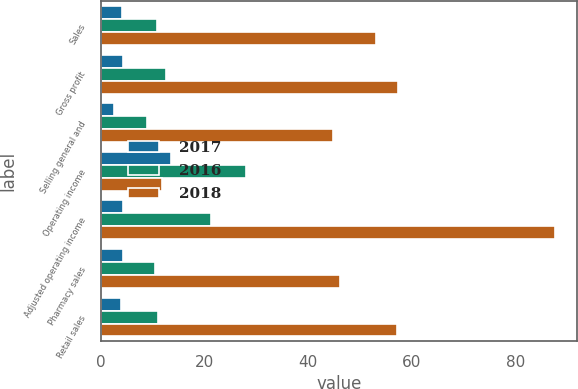Convert chart. <chart><loc_0><loc_0><loc_500><loc_500><stacked_bar_chart><ecel><fcel>Sales<fcel>Gross profit<fcel>Selling general and<fcel>Operating income<fcel>Adjusted operating income<fcel>Pharmacy sales<fcel>Retail sales<nl><fcel>2017<fcel>4<fcel>4.3<fcel>2.6<fcel>13.6<fcel>4.2<fcel>4.3<fcel>3.8<nl><fcel>2016<fcel>10.9<fcel>12.5<fcel>8.9<fcel>28<fcel>21.3<fcel>10.5<fcel>11.1<nl><fcel>2018<fcel>53.1<fcel>57.4<fcel>44.7<fcel>11.8<fcel>87.5<fcel>46.2<fcel>57.1<nl></chart> 